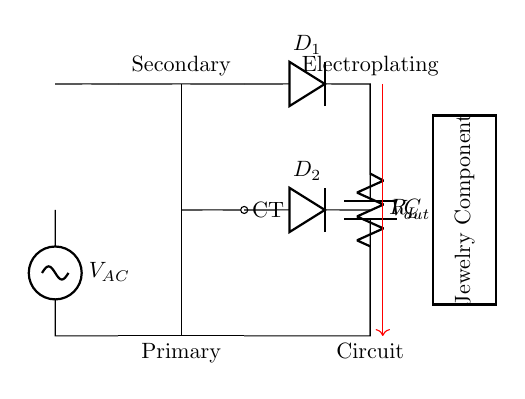What is the function of the component labeled "C"? The component labeled "C" is a capacitor, which is used to smooth out the voltage fluctuations in the output of the rectifier circuit. Capacitors charge and discharge quickly, providing a more stable voltage level for electroplating.
Answer: Capacitor What kind of transformer is used in this circuit? The transformer in this circuit is a center-tapped transformer, which provides two equal voltages relative to the center tap, allowing for a full-wave rectification. Center-tapping allows the diodes to utilize both halves of the AC waveform.
Answer: Center-tapped transformer How many diodes are present in this circuit? There are two diodes present in this circuit. Diodes are used to allow current to flow in only one direction, which is essential for converting AC to DC in a rectifier circuit.
Answer: Two What is the load in this circuit? The load in this circuit is represented by the rectangular shape labeled "Jewelry Component." This indicates that the circuit is designed to provide current for electroplating jewelry items.
Answer: Jewelry Component What type of circuit is this? This circuit is a rectifier circuit, specifically designed for electroplating. It converts alternating current (AC) from the transformer into direct current (DC), which is required for the electroplating process.
Answer: Rectifier circuit 